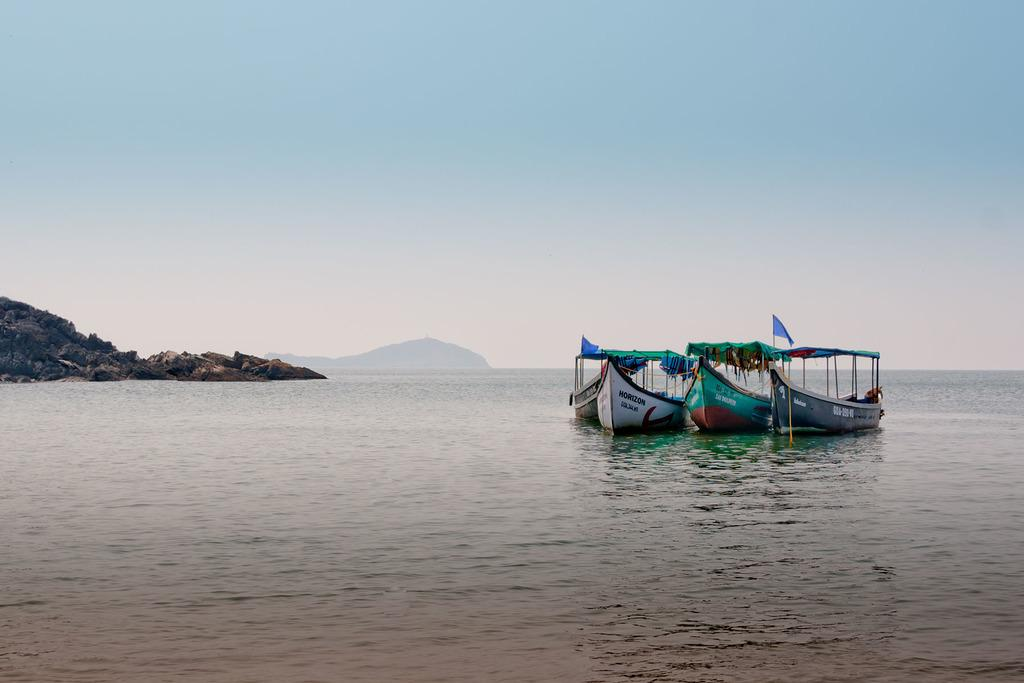What is at the bottom of the image? There is water at the bottom of the image. What is on the water in the image? There are boats with poles and flags on the water. What can be seen on the left side of the image? There are hills on the left side of the image. What is visible at the top of the image? The sky is visible at the top of the image. What type of quiet activity is happening on the boats in the image? There is no indication of any activity happening on the boats in the image, and they are not described as being quiet or engaged in any activity. 